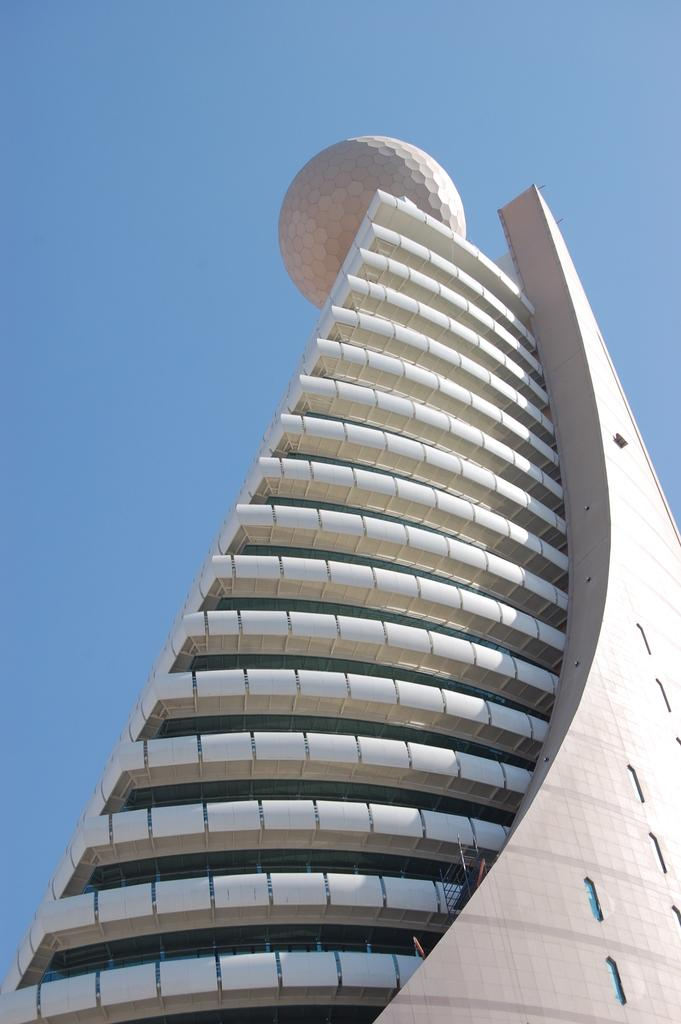What is the main subject of the image? The main subject of the image is a skyscraper. Where is the skyscraper located in the image? The skyscraper is in the center of the image. What is present at the top of the skyscraper? There is a circular model at the top of the skyscraper. How many ladybugs can be seen crawling on the coach in the image? There are no ladybugs or coaches present in the image. 